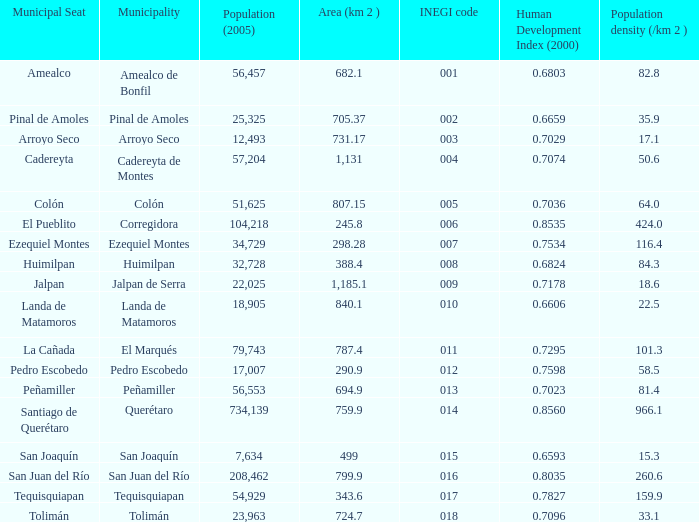WHich INEGI code has a Population density (/km 2 ) smaller than 81.4 and 0.6593 Human Development Index (2000)? 15.0. 